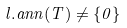Convert formula to latex. <formula><loc_0><loc_0><loc_500><loc_500>l . a n n ( T ) \ne \{ 0 \}</formula> 